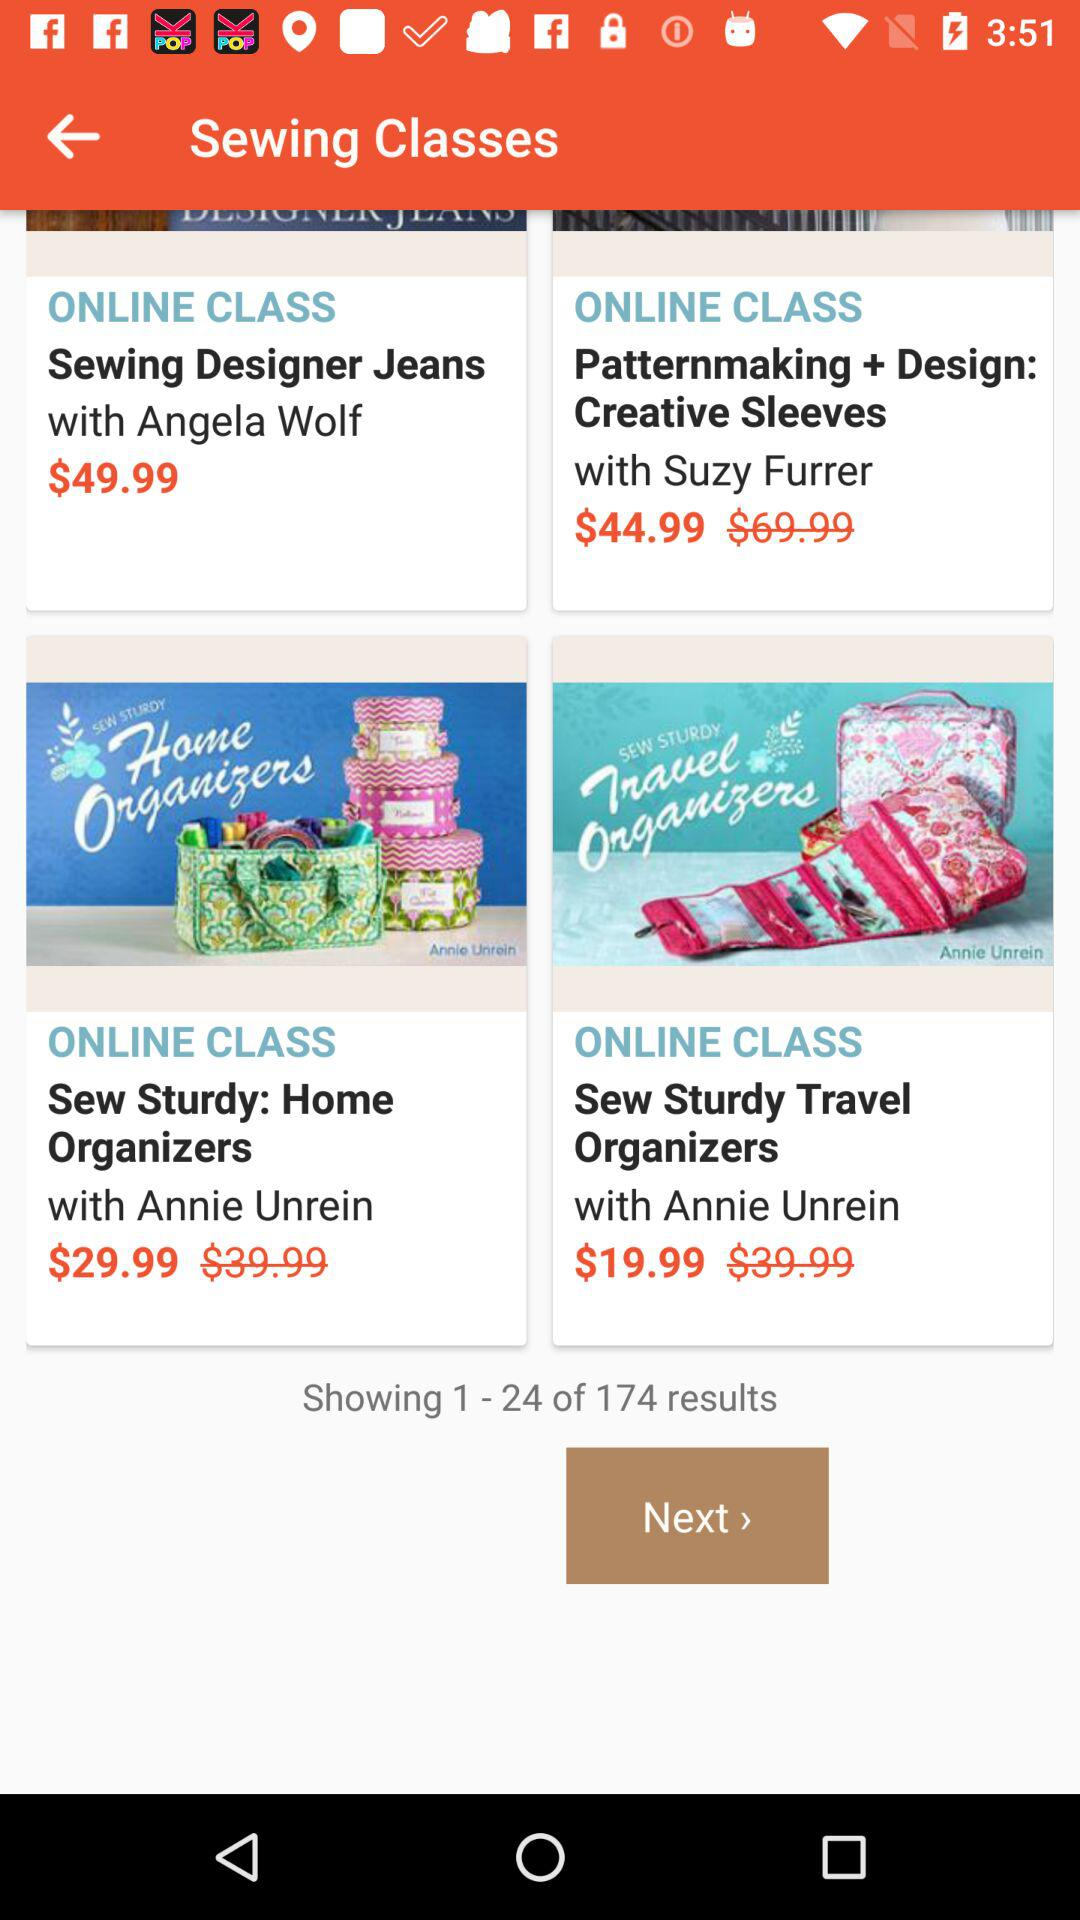Name the online class whose price is $49.99? The name of the online class is "Sewing Designer Jeans". 